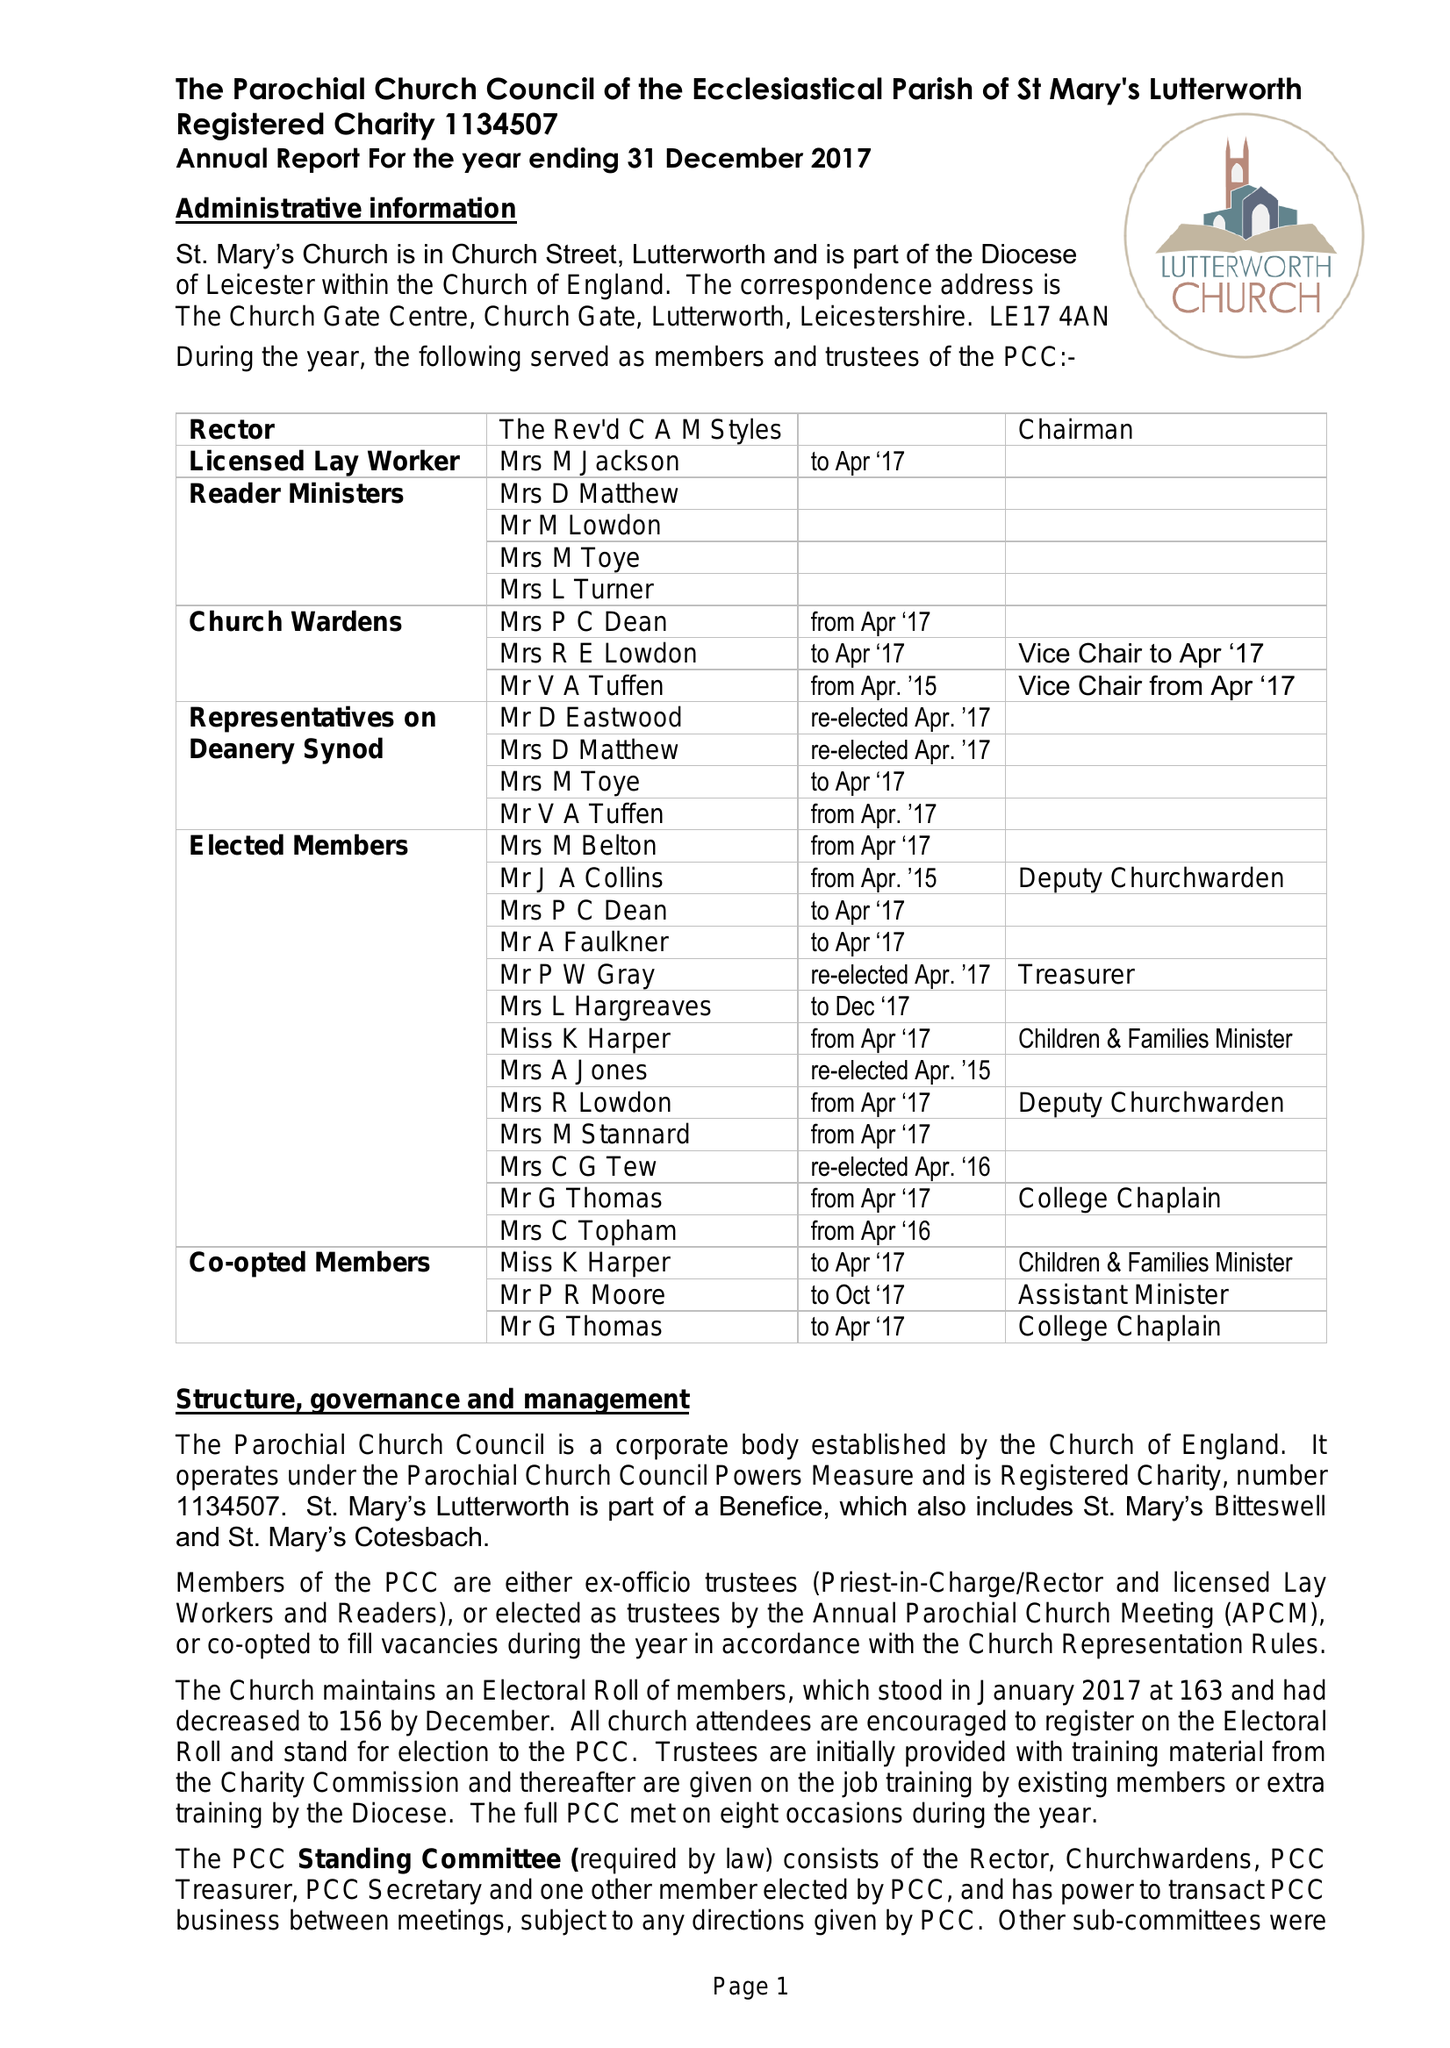What is the value for the address__post_town?
Answer the question using a single word or phrase. LUTTERWORTH 